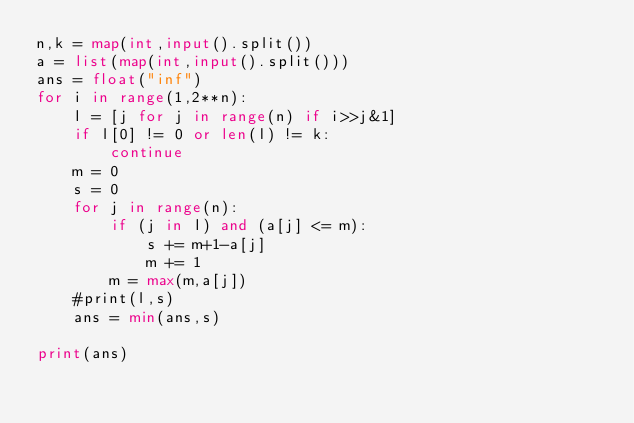Convert code to text. <code><loc_0><loc_0><loc_500><loc_500><_Python_>n,k = map(int,input().split())
a = list(map(int,input().split()))
ans = float("inf")
for i in range(1,2**n):
    l = [j for j in range(n) if i>>j&1]
    if l[0] != 0 or len(l) != k:
        continue
    m = 0
    s = 0
    for j in range(n):
        if (j in l) and (a[j] <= m):
            s += m+1-a[j]
            m += 1
        m = max(m,a[j])
    #print(l,s)
    ans = min(ans,s)

print(ans)</code> 